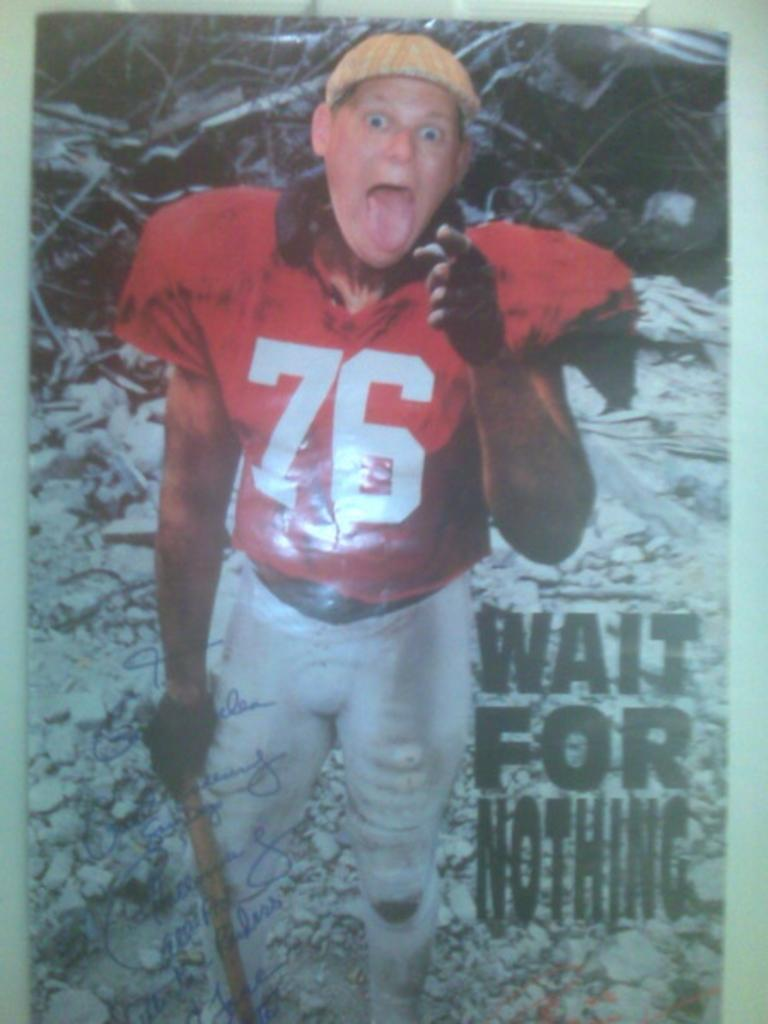<image>
Relay a brief, clear account of the picture shown. A man is wearing a jersey number 76 with the phrase "wait for nothing" printed on the photo. 